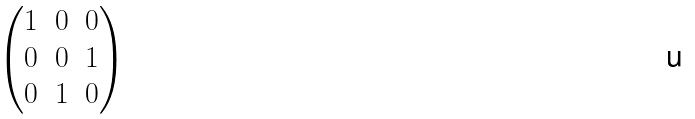Convert formula to latex. <formula><loc_0><loc_0><loc_500><loc_500>\begin{pmatrix} 1 & 0 & 0 \\ 0 & 0 & 1 \\ 0 & 1 & 0 \end{pmatrix}</formula> 